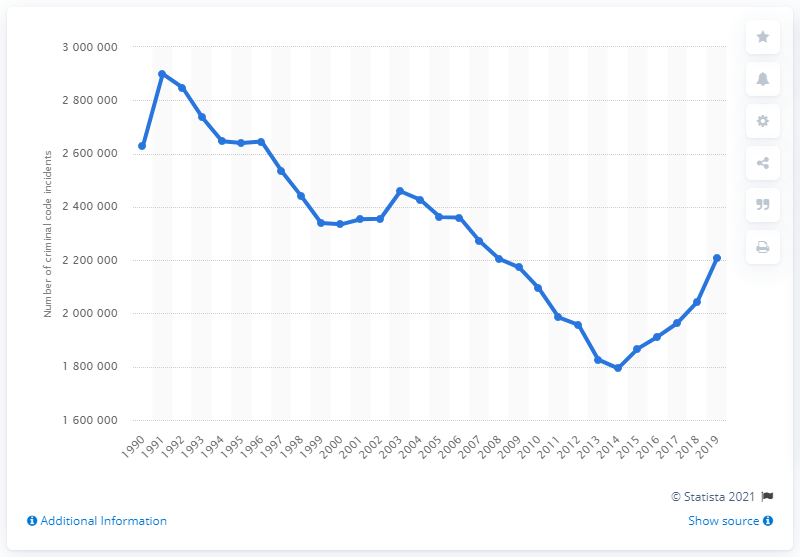Indicate a few pertinent items in this graphic. In 2019, a total of 2208076 crimes were reported in Canada. 